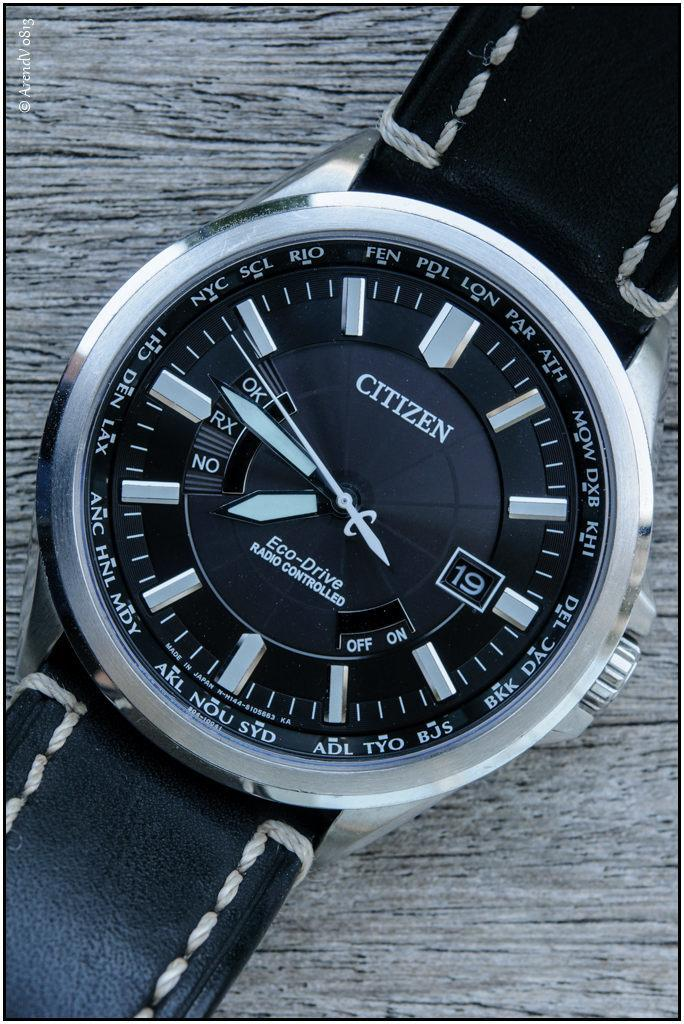Provide a one-sentence caption for the provided image. A close up of a Citizen phone with the time at 7:46. 